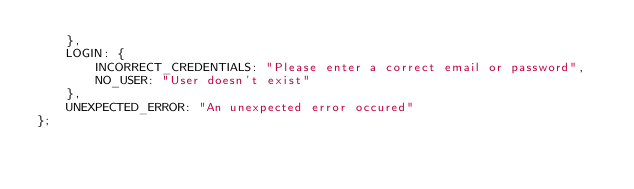Convert code to text. <code><loc_0><loc_0><loc_500><loc_500><_TypeScript_>    },
    LOGIN: {
        INCORRECT_CREDENTIALS: "Please enter a correct email or password",
        NO_USER: "User doesn't exist"
    },
    UNEXPECTED_ERROR: "An unexpected error occured"
};
</code> 